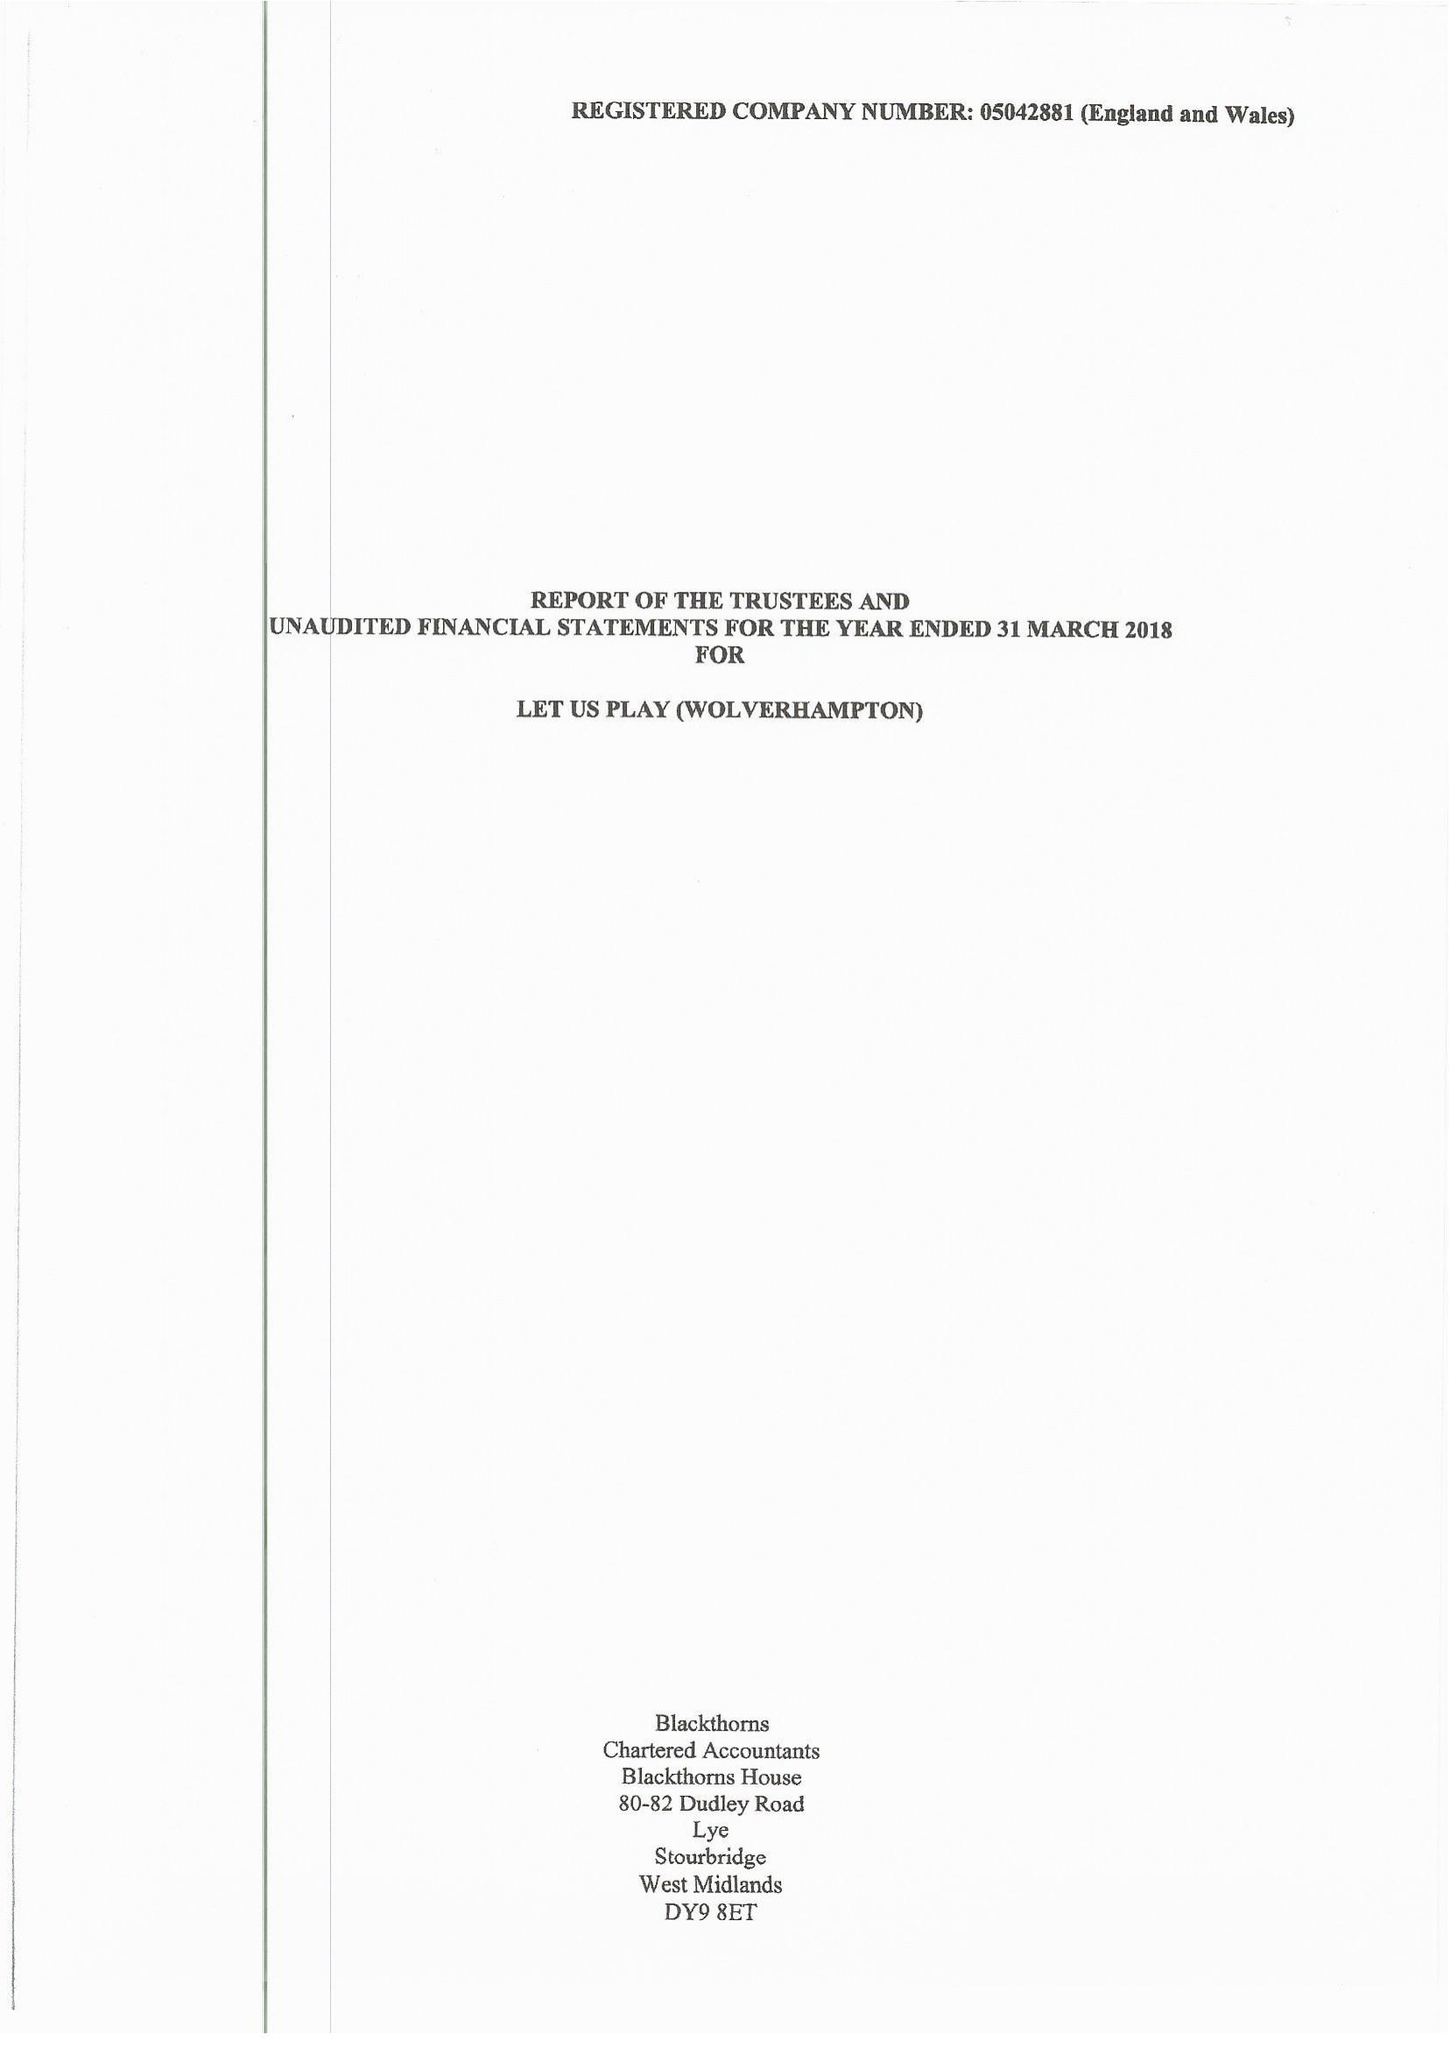What is the value for the address__post_town?
Answer the question using a single word or phrase. WOLVERHAMPTON 